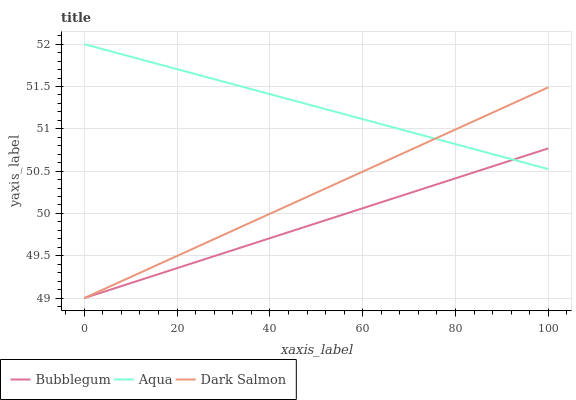Does Bubblegum have the minimum area under the curve?
Answer yes or no. Yes. Does Aqua have the maximum area under the curve?
Answer yes or no. Yes. Does Dark Salmon have the minimum area under the curve?
Answer yes or no. No. Does Dark Salmon have the maximum area under the curve?
Answer yes or no. No. Is Aqua the smoothest?
Answer yes or no. Yes. Is Dark Salmon the roughest?
Answer yes or no. Yes. Is Bubblegum the smoothest?
Answer yes or no. No. Is Bubblegum the roughest?
Answer yes or no. No. Does Dark Salmon have the lowest value?
Answer yes or no. Yes. Does Aqua have the highest value?
Answer yes or no. Yes. Does Dark Salmon have the highest value?
Answer yes or no. No. Does Aqua intersect Bubblegum?
Answer yes or no. Yes. Is Aqua less than Bubblegum?
Answer yes or no. No. Is Aqua greater than Bubblegum?
Answer yes or no. No. 